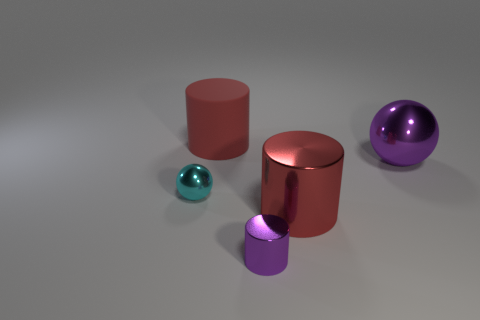Subtract all cyan spheres. How many red cylinders are left? 2 Subtract all big cylinders. How many cylinders are left? 1 Add 2 tiny purple blocks. How many objects exist? 7 Subtract all cylinders. How many objects are left? 2 Subtract all purple objects. Subtract all tiny shiny things. How many objects are left? 1 Add 1 small purple things. How many small purple things are left? 2 Add 3 big shiny cylinders. How many big shiny cylinders exist? 4 Subtract 0 blue blocks. How many objects are left? 5 